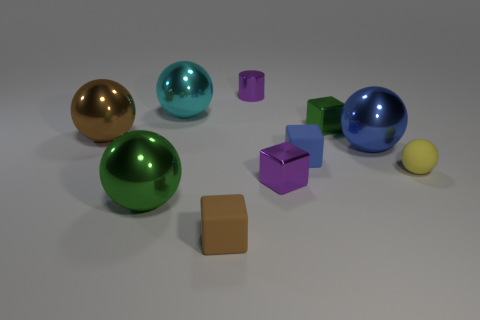The sphere that is both in front of the big blue thing and on the left side of the blue metal object is made of what material?
Provide a succinct answer. Metal. There is a metallic cylinder; is it the same color as the large thing to the right of the green metal cube?
Your answer should be very brief. No. What material is the green thing that is the same size as the brown rubber thing?
Provide a short and direct response. Metal. Are there any brown blocks that have the same material as the tiny green block?
Provide a short and direct response. No. What number of cyan matte cubes are there?
Offer a very short reply. 0. Does the purple block have the same material as the brown object behind the tiny ball?
Give a very brief answer. Yes. There is a small object that is the same color as the tiny cylinder; what material is it?
Your response must be concise. Metal. What number of large balls have the same color as the small ball?
Keep it short and to the point. 0. The brown metal ball is what size?
Offer a very short reply. Large. Does the yellow object have the same shape as the green metallic thing right of the big cyan sphere?
Your response must be concise. No. 